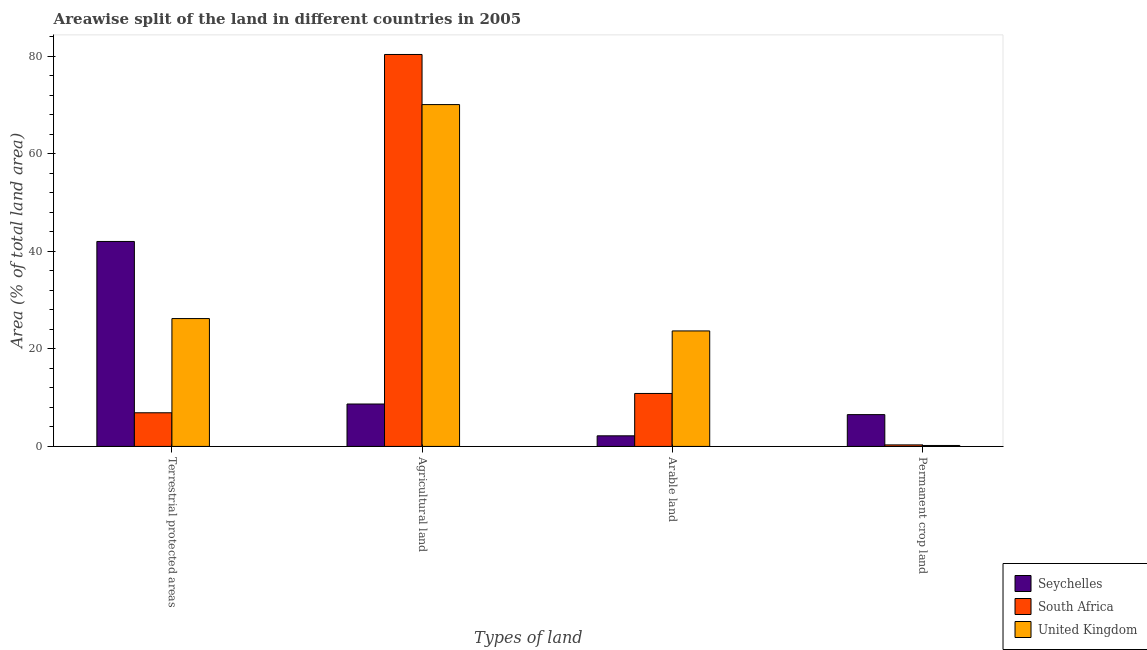How many different coloured bars are there?
Your answer should be very brief. 3. How many bars are there on the 4th tick from the left?
Give a very brief answer. 3. What is the label of the 4th group of bars from the left?
Give a very brief answer. Permanent crop land. What is the percentage of area under arable land in United Kingdom?
Make the answer very short. 23.68. Across all countries, what is the maximum percentage of area under permanent crop land?
Your response must be concise. 6.52. Across all countries, what is the minimum percentage of area under agricultural land?
Offer a very short reply. 8.7. In which country was the percentage of land under terrestrial protection maximum?
Your answer should be compact. Seychelles. In which country was the percentage of area under arable land minimum?
Provide a short and direct response. Seychelles. What is the total percentage of area under agricultural land in the graph?
Make the answer very short. 159.14. What is the difference between the percentage of land under terrestrial protection in United Kingdom and that in South Africa?
Your answer should be very brief. 19.31. What is the difference between the percentage of area under agricultural land in Seychelles and the percentage of land under terrestrial protection in South Africa?
Give a very brief answer. 1.79. What is the average percentage of land under terrestrial protection per country?
Offer a terse response. 25.05. What is the difference between the percentage of area under permanent crop land and percentage of land under terrestrial protection in Seychelles?
Your answer should be compact. -35.5. In how many countries, is the percentage of area under arable land greater than 12 %?
Provide a short and direct response. 1. What is the ratio of the percentage of area under arable land in United Kingdom to that in Seychelles?
Offer a terse response. 10.89. Is the difference between the percentage of area under agricultural land in United Kingdom and South Africa greater than the difference between the percentage of land under terrestrial protection in United Kingdom and South Africa?
Provide a succinct answer. No. What is the difference between the highest and the second highest percentage of land under terrestrial protection?
Provide a short and direct response. 15.81. What is the difference between the highest and the lowest percentage of area under agricultural land?
Your response must be concise. 71.66. In how many countries, is the percentage of area under permanent crop land greater than the average percentage of area under permanent crop land taken over all countries?
Provide a succinct answer. 1. Is the sum of the percentage of area under permanent crop land in United Kingdom and South Africa greater than the maximum percentage of area under agricultural land across all countries?
Offer a terse response. No. What does the 1st bar from the left in Arable land represents?
Make the answer very short. Seychelles. What does the 2nd bar from the right in Permanent crop land represents?
Keep it short and to the point. South Africa. Are all the bars in the graph horizontal?
Provide a short and direct response. No. What is the difference between two consecutive major ticks on the Y-axis?
Make the answer very short. 20. Does the graph contain any zero values?
Keep it short and to the point. No. Where does the legend appear in the graph?
Your answer should be very brief. Bottom right. How many legend labels are there?
Ensure brevity in your answer.  3. What is the title of the graph?
Offer a very short reply. Areawise split of the land in different countries in 2005. Does "Papua New Guinea" appear as one of the legend labels in the graph?
Offer a very short reply. No. What is the label or title of the X-axis?
Offer a very short reply. Types of land. What is the label or title of the Y-axis?
Make the answer very short. Area (% of total land area). What is the Area (% of total land area) in Seychelles in Terrestrial protected areas?
Make the answer very short. 42.02. What is the Area (% of total land area) of South Africa in Terrestrial protected areas?
Give a very brief answer. 6.9. What is the Area (% of total land area) of United Kingdom in Terrestrial protected areas?
Your answer should be compact. 26.21. What is the Area (% of total land area) of Seychelles in Agricultural land?
Make the answer very short. 8.7. What is the Area (% of total land area) in South Africa in Agricultural land?
Make the answer very short. 80.36. What is the Area (% of total land area) of United Kingdom in Agricultural land?
Your response must be concise. 70.09. What is the Area (% of total land area) in Seychelles in Arable land?
Keep it short and to the point. 2.17. What is the Area (% of total land area) in South Africa in Arable land?
Give a very brief answer. 10.86. What is the Area (% of total land area) of United Kingdom in Arable land?
Give a very brief answer. 23.68. What is the Area (% of total land area) of Seychelles in Permanent crop land?
Your response must be concise. 6.52. What is the Area (% of total land area) in South Africa in Permanent crop land?
Your answer should be compact. 0.31. What is the Area (% of total land area) of United Kingdom in Permanent crop land?
Give a very brief answer. 0.19. Across all Types of land, what is the maximum Area (% of total land area) in Seychelles?
Ensure brevity in your answer.  42.02. Across all Types of land, what is the maximum Area (% of total land area) of South Africa?
Provide a short and direct response. 80.36. Across all Types of land, what is the maximum Area (% of total land area) of United Kingdom?
Your response must be concise. 70.09. Across all Types of land, what is the minimum Area (% of total land area) in Seychelles?
Give a very brief answer. 2.17. Across all Types of land, what is the minimum Area (% of total land area) in South Africa?
Ensure brevity in your answer.  0.31. Across all Types of land, what is the minimum Area (% of total land area) of United Kingdom?
Provide a succinct answer. 0.19. What is the total Area (% of total land area) of Seychelles in the graph?
Your answer should be very brief. 59.41. What is the total Area (% of total land area) in South Africa in the graph?
Offer a terse response. 98.43. What is the total Area (% of total land area) of United Kingdom in the graph?
Offer a very short reply. 120.18. What is the difference between the Area (% of total land area) of Seychelles in Terrestrial protected areas and that in Agricultural land?
Your response must be concise. 33.33. What is the difference between the Area (% of total land area) of South Africa in Terrestrial protected areas and that in Agricultural land?
Offer a terse response. -73.46. What is the difference between the Area (% of total land area) in United Kingdom in Terrestrial protected areas and that in Agricultural land?
Keep it short and to the point. -43.87. What is the difference between the Area (% of total land area) in Seychelles in Terrestrial protected areas and that in Arable land?
Your answer should be very brief. 39.85. What is the difference between the Area (% of total land area) in South Africa in Terrestrial protected areas and that in Arable land?
Offer a very short reply. -3.96. What is the difference between the Area (% of total land area) in United Kingdom in Terrestrial protected areas and that in Arable land?
Keep it short and to the point. 2.53. What is the difference between the Area (% of total land area) in Seychelles in Terrestrial protected areas and that in Permanent crop land?
Your answer should be compact. 35.5. What is the difference between the Area (% of total land area) of South Africa in Terrestrial protected areas and that in Permanent crop land?
Keep it short and to the point. 6.59. What is the difference between the Area (% of total land area) in United Kingdom in Terrestrial protected areas and that in Permanent crop land?
Your answer should be very brief. 26.02. What is the difference between the Area (% of total land area) of Seychelles in Agricultural land and that in Arable land?
Offer a very short reply. 6.52. What is the difference between the Area (% of total land area) of South Africa in Agricultural land and that in Arable land?
Offer a very short reply. 69.5. What is the difference between the Area (% of total land area) in United Kingdom in Agricultural land and that in Arable land?
Your response must be concise. 46.41. What is the difference between the Area (% of total land area) of Seychelles in Agricultural land and that in Permanent crop land?
Give a very brief answer. 2.17. What is the difference between the Area (% of total land area) of South Africa in Agricultural land and that in Permanent crop land?
Offer a very short reply. 80.05. What is the difference between the Area (% of total land area) in United Kingdom in Agricultural land and that in Permanent crop land?
Your answer should be compact. 69.89. What is the difference between the Area (% of total land area) of Seychelles in Arable land and that in Permanent crop land?
Offer a terse response. -4.35. What is the difference between the Area (% of total land area) of South Africa in Arable land and that in Permanent crop land?
Your response must be concise. 10.55. What is the difference between the Area (% of total land area) of United Kingdom in Arable land and that in Permanent crop land?
Make the answer very short. 23.49. What is the difference between the Area (% of total land area) in Seychelles in Terrestrial protected areas and the Area (% of total land area) in South Africa in Agricultural land?
Offer a very short reply. -38.34. What is the difference between the Area (% of total land area) of Seychelles in Terrestrial protected areas and the Area (% of total land area) of United Kingdom in Agricultural land?
Ensure brevity in your answer.  -28.06. What is the difference between the Area (% of total land area) of South Africa in Terrestrial protected areas and the Area (% of total land area) of United Kingdom in Agricultural land?
Your answer should be compact. -63.19. What is the difference between the Area (% of total land area) in Seychelles in Terrestrial protected areas and the Area (% of total land area) in South Africa in Arable land?
Provide a short and direct response. 31.16. What is the difference between the Area (% of total land area) of Seychelles in Terrestrial protected areas and the Area (% of total land area) of United Kingdom in Arable land?
Provide a succinct answer. 18.34. What is the difference between the Area (% of total land area) of South Africa in Terrestrial protected areas and the Area (% of total land area) of United Kingdom in Arable land?
Provide a short and direct response. -16.78. What is the difference between the Area (% of total land area) of Seychelles in Terrestrial protected areas and the Area (% of total land area) of South Africa in Permanent crop land?
Your answer should be compact. 41.71. What is the difference between the Area (% of total land area) of Seychelles in Terrestrial protected areas and the Area (% of total land area) of United Kingdom in Permanent crop land?
Offer a terse response. 41.83. What is the difference between the Area (% of total land area) of South Africa in Terrestrial protected areas and the Area (% of total land area) of United Kingdom in Permanent crop land?
Ensure brevity in your answer.  6.71. What is the difference between the Area (% of total land area) of Seychelles in Agricultural land and the Area (% of total land area) of South Africa in Arable land?
Provide a succinct answer. -2.17. What is the difference between the Area (% of total land area) of Seychelles in Agricultural land and the Area (% of total land area) of United Kingdom in Arable land?
Make the answer very short. -14.98. What is the difference between the Area (% of total land area) in South Africa in Agricultural land and the Area (% of total land area) in United Kingdom in Arable land?
Your response must be concise. 56.68. What is the difference between the Area (% of total land area) in Seychelles in Agricultural land and the Area (% of total land area) in South Africa in Permanent crop land?
Make the answer very short. 8.38. What is the difference between the Area (% of total land area) of Seychelles in Agricultural land and the Area (% of total land area) of United Kingdom in Permanent crop land?
Provide a succinct answer. 8.5. What is the difference between the Area (% of total land area) of South Africa in Agricultural land and the Area (% of total land area) of United Kingdom in Permanent crop land?
Give a very brief answer. 80.17. What is the difference between the Area (% of total land area) of Seychelles in Arable land and the Area (% of total land area) of South Africa in Permanent crop land?
Ensure brevity in your answer.  1.86. What is the difference between the Area (% of total land area) in Seychelles in Arable land and the Area (% of total land area) in United Kingdom in Permanent crop land?
Provide a short and direct response. 1.98. What is the difference between the Area (% of total land area) in South Africa in Arable land and the Area (% of total land area) in United Kingdom in Permanent crop land?
Give a very brief answer. 10.67. What is the average Area (% of total land area) of Seychelles per Types of land?
Make the answer very short. 14.85. What is the average Area (% of total land area) in South Africa per Types of land?
Give a very brief answer. 24.61. What is the average Area (% of total land area) in United Kingdom per Types of land?
Your response must be concise. 30.04. What is the difference between the Area (% of total land area) in Seychelles and Area (% of total land area) in South Africa in Terrestrial protected areas?
Your response must be concise. 35.12. What is the difference between the Area (% of total land area) in Seychelles and Area (% of total land area) in United Kingdom in Terrestrial protected areas?
Your answer should be very brief. 15.81. What is the difference between the Area (% of total land area) in South Africa and Area (% of total land area) in United Kingdom in Terrestrial protected areas?
Keep it short and to the point. -19.31. What is the difference between the Area (% of total land area) in Seychelles and Area (% of total land area) in South Africa in Agricultural land?
Provide a short and direct response. -71.66. What is the difference between the Area (% of total land area) in Seychelles and Area (% of total land area) in United Kingdom in Agricultural land?
Provide a succinct answer. -61.39. What is the difference between the Area (% of total land area) of South Africa and Area (% of total land area) of United Kingdom in Agricultural land?
Your answer should be compact. 10.27. What is the difference between the Area (% of total land area) in Seychelles and Area (% of total land area) in South Africa in Arable land?
Your answer should be very brief. -8.69. What is the difference between the Area (% of total land area) in Seychelles and Area (% of total land area) in United Kingdom in Arable land?
Keep it short and to the point. -21.51. What is the difference between the Area (% of total land area) of South Africa and Area (% of total land area) of United Kingdom in Arable land?
Make the answer very short. -12.82. What is the difference between the Area (% of total land area) of Seychelles and Area (% of total land area) of South Africa in Permanent crop land?
Make the answer very short. 6.21. What is the difference between the Area (% of total land area) in Seychelles and Area (% of total land area) in United Kingdom in Permanent crop land?
Keep it short and to the point. 6.33. What is the difference between the Area (% of total land area) in South Africa and Area (% of total land area) in United Kingdom in Permanent crop land?
Make the answer very short. 0.12. What is the ratio of the Area (% of total land area) of Seychelles in Terrestrial protected areas to that in Agricultural land?
Provide a succinct answer. 4.83. What is the ratio of the Area (% of total land area) in South Africa in Terrestrial protected areas to that in Agricultural land?
Keep it short and to the point. 0.09. What is the ratio of the Area (% of total land area) of United Kingdom in Terrestrial protected areas to that in Agricultural land?
Keep it short and to the point. 0.37. What is the ratio of the Area (% of total land area) of Seychelles in Terrestrial protected areas to that in Arable land?
Offer a terse response. 19.33. What is the ratio of the Area (% of total land area) of South Africa in Terrestrial protected areas to that in Arable land?
Your answer should be very brief. 0.64. What is the ratio of the Area (% of total land area) in United Kingdom in Terrestrial protected areas to that in Arable land?
Keep it short and to the point. 1.11. What is the ratio of the Area (% of total land area) of Seychelles in Terrestrial protected areas to that in Permanent crop land?
Ensure brevity in your answer.  6.44. What is the ratio of the Area (% of total land area) of South Africa in Terrestrial protected areas to that in Permanent crop land?
Your answer should be compact. 22.03. What is the ratio of the Area (% of total land area) of United Kingdom in Terrestrial protected areas to that in Permanent crop land?
Provide a succinct answer. 134.94. What is the ratio of the Area (% of total land area) of South Africa in Agricultural land to that in Arable land?
Give a very brief answer. 7.4. What is the ratio of the Area (% of total land area) of United Kingdom in Agricultural land to that in Arable land?
Your answer should be compact. 2.96. What is the ratio of the Area (% of total land area) in Seychelles in Agricultural land to that in Permanent crop land?
Keep it short and to the point. 1.33. What is the ratio of the Area (% of total land area) of South Africa in Agricultural land to that in Permanent crop land?
Keep it short and to the point. 256.53. What is the ratio of the Area (% of total land area) of United Kingdom in Agricultural land to that in Permanent crop land?
Your response must be concise. 360.77. What is the ratio of the Area (% of total land area) in Seychelles in Arable land to that in Permanent crop land?
Offer a very short reply. 0.33. What is the ratio of the Area (% of total land area) of South Africa in Arable land to that in Permanent crop land?
Keep it short and to the point. 34.67. What is the ratio of the Area (% of total land area) of United Kingdom in Arable land to that in Permanent crop land?
Keep it short and to the point. 121.89. What is the difference between the highest and the second highest Area (% of total land area) in Seychelles?
Offer a very short reply. 33.33. What is the difference between the highest and the second highest Area (% of total land area) of South Africa?
Ensure brevity in your answer.  69.5. What is the difference between the highest and the second highest Area (% of total land area) of United Kingdom?
Give a very brief answer. 43.87. What is the difference between the highest and the lowest Area (% of total land area) of Seychelles?
Keep it short and to the point. 39.85. What is the difference between the highest and the lowest Area (% of total land area) of South Africa?
Your answer should be compact. 80.05. What is the difference between the highest and the lowest Area (% of total land area) of United Kingdom?
Provide a succinct answer. 69.89. 